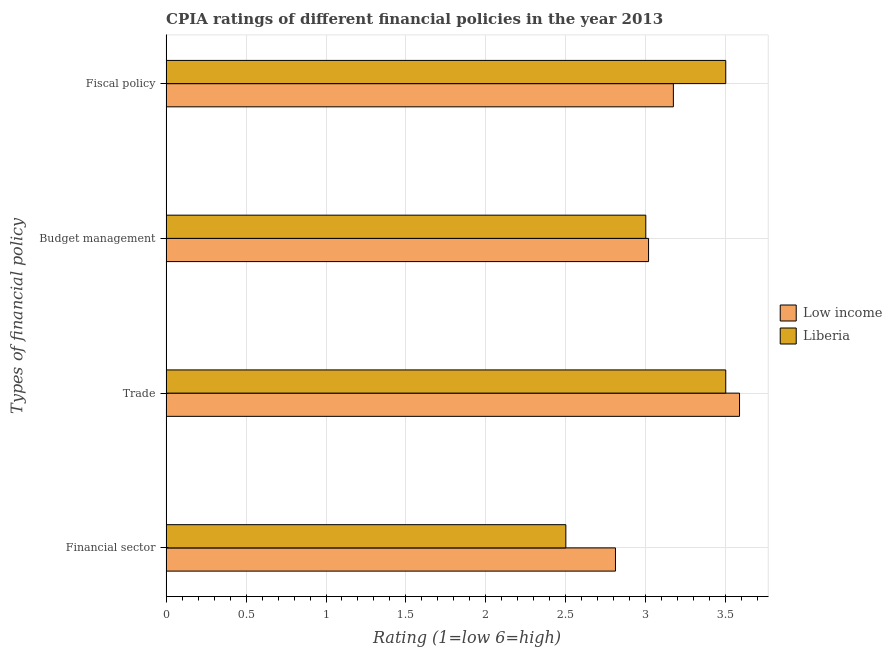How many groups of bars are there?
Make the answer very short. 4. Are the number of bars per tick equal to the number of legend labels?
Offer a very short reply. Yes. Are the number of bars on each tick of the Y-axis equal?
Ensure brevity in your answer.  Yes. How many bars are there on the 1st tick from the top?
Offer a very short reply. 2. What is the label of the 2nd group of bars from the top?
Ensure brevity in your answer.  Budget management. Across all countries, what is the minimum cpia rating of fiscal policy?
Your response must be concise. 3.17. In which country was the cpia rating of budget management maximum?
Offer a terse response. Low income. What is the total cpia rating of fiscal policy in the graph?
Give a very brief answer. 6.67. What is the difference between the cpia rating of trade in Liberia and that in Low income?
Provide a short and direct response. -0.09. What is the difference between the cpia rating of financial sector in Liberia and the cpia rating of trade in Low income?
Provide a succinct answer. -1.09. What is the average cpia rating of financial sector per country?
Your response must be concise. 2.66. What is the difference between the cpia rating of trade and cpia rating of fiscal policy in Low income?
Make the answer very short. 0.41. In how many countries, is the cpia rating of budget management greater than 1.7 ?
Keep it short and to the point. 2. What is the ratio of the cpia rating of fiscal policy in Liberia to that in Low income?
Your answer should be very brief. 1.1. What is the difference between the highest and the second highest cpia rating of fiscal policy?
Provide a short and direct response. 0.33. What is the difference between the highest and the lowest cpia rating of fiscal policy?
Keep it short and to the point. 0.33. What does the 1st bar from the top in Financial sector represents?
Your answer should be compact. Liberia. What does the 2nd bar from the bottom in Fiscal policy represents?
Offer a very short reply. Liberia. Is it the case that in every country, the sum of the cpia rating of financial sector and cpia rating of trade is greater than the cpia rating of budget management?
Provide a short and direct response. Yes. How many bars are there?
Your answer should be compact. 8. What is the difference between two consecutive major ticks on the X-axis?
Your response must be concise. 0.5. Are the values on the major ticks of X-axis written in scientific E-notation?
Provide a succinct answer. No. Does the graph contain grids?
Provide a short and direct response. Yes. What is the title of the graph?
Offer a terse response. CPIA ratings of different financial policies in the year 2013. What is the label or title of the Y-axis?
Keep it short and to the point. Types of financial policy. What is the Rating (1=low 6=high) in Low income in Financial sector?
Give a very brief answer. 2.81. What is the Rating (1=low 6=high) in Liberia in Financial sector?
Provide a short and direct response. 2.5. What is the Rating (1=low 6=high) in Low income in Trade?
Your answer should be compact. 3.59. What is the Rating (1=low 6=high) of Low income in Budget management?
Offer a very short reply. 3.02. What is the Rating (1=low 6=high) in Low income in Fiscal policy?
Keep it short and to the point. 3.17. What is the Rating (1=low 6=high) in Liberia in Fiscal policy?
Offer a terse response. 3.5. Across all Types of financial policy, what is the maximum Rating (1=low 6=high) in Low income?
Offer a very short reply. 3.59. Across all Types of financial policy, what is the maximum Rating (1=low 6=high) of Liberia?
Make the answer very short. 3.5. Across all Types of financial policy, what is the minimum Rating (1=low 6=high) in Low income?
Your answer should be compact. 2.81. What is the total Rating (1=low 6=high) in Low income in the graph?
Provide a succinct answer. 12.59. What is the difference between the Rating (1=low 6=high) of Low income in Financial sector and that in Trade?
Make the answer very short. -0.78. What is the difference between the Rating (1=low 6=high) of Low income in Financial sector and that in Budget management?
Make the answer very short. -0.21. What is the difference between the Rating (1=low 6=high) of Low income in Financial sector and that in Fiscal policy?
Provide a succinct answer. -0.36. What is the difference between the Rating (1=low 6=high) of Liberia in Financial sector and that in Fiscal policy?
Provide a succinct answer. -1. What is the difference between the Rating (1=low 6=high) of Low income in Trade and that in Budget management?
Offer a terse response. 0.57. What is the difference between the Rating (1=low 6=high) of Liberia in Trade and that in Budget management?
Give a very brief answer. 0.5. What is the difference between the Rating (1=low 6=high) in Low income in Trade and that in Fiscal policy?
Give a very brief answer. 0.41. What is the difference between the Rating (1=low 6=high) in Liberia in Trade and that in Fiscal policy?
Offer a very short reply. 0. What is the difference between the Rating (1=low 6=high) of Low income in Budget management and that in Fiscal policy?
Your response must be concise. -0.16. What is the difference between the Rating (1=low 6=high) of Liberia in Budget management and that in Fiscal policy?
Offer a very short reply. -0.5. What is the difference between the Rating (1=low 6=high) of Low income in Financial sector and the Rating (1=low 6=high) of Liberia in Trade?
Ensure brevity in your answer.  -0.69. What is the difference between the Rating (1=low 6=high) in Low income in Financial sector and the Rating (1=low 6=high) in Liberia in Budget management?
Offer a terse response. -0.19. What is the difference between the Rating (1=low 6=high) in Low income in Financial sector and the Rating (1=low 6=high) in Liberia in Fiscal policy?
Your response must be concise. -0.69. What is the difference between the Rating (1=low 6=high) of Low income in Trade and the Rating (1=low 6=high) of Liberia in Budget management?
Your answer should be very brief. 0.59. What is the difference between the Rating (1=low 6=high) in Low income in Trade and the Rating (1=low 6=high) in Liberia in Fiscal policy?
Make the answer very short. 0.09. What is the difference between the Rating (1=low 6=high) in Low income in Budget management and the Rating (1=low 6=high) in Liberia in Fiscal policy?
Provide a succinct answer. -0.48. What is the average Rating (1=low 6=high) of Low income per Types of financial policy?
Give a very brief answer. 3.15. What is the average Rating (1=low 6=high) of Liberia per Types of financial policy?
Provide a short and direct response. 3.12. What is the difference between the Rating (1=low 6=high) of Low income and Rating (1=low 6=high) of Liberia in Financial sector?
Make the answer very short. 0.31. What is the difference between the Rating (1=low 6=high) of Low income and Rating (1=low 6=high) of Liberia in Trade?
Provide a short and direct response. 0.09. What is the difference between the Rating (1=low 6=high) in Low income and Rating (1=low 6=high) in Liberia in Budget management?
Your answer should be compact. 0.02. What is the difference between the Rating (1=low 6=high) in Low income and Rating (1=low 6=high) in Liberia in Fiscal policy?
Provide a succinct answer. -0.33. What is the ratio of the Rating (1=low 6=high) of Low income in Financial sector to that in Trade?
Offer a very short reply. 0.78. What is the ratio of the Rating (1=low 6=high) of Low income in Financial sector to that in Budget management?
Offer a terse response. 0.93. What is the ratio of the Rating (1=low 6=high) in Liberia in Financial sector to that in Budget management?
Ensure brevity in your answer.  0.83. What is the ratio of the Rating (1=low 6=high) in Low income in Financial sector to that in Fiscal policy?
Give a very brief answer. 0.89. What is the ratio of the Rating (1=low 6=high) of Low income in Trade to that in Budget management?
Provide a succinct answer. 1.19. What is the ratio of the Rating (1=low 6=high) in Liberia in Trade to that in Budget management?
Your response must be concise. 1.17. What is the ratio of the Rating (1=low 6=high) in Low income in Trade to that in Fiscal policy?
Offer a very short reply. 1.13. What is the ratio of the Rating (1=low 6=high) in Low income in Budget management to that in Fiscal policy?
Keep it short and to the point. 0.95. What is the ratio of the Rating (1=low 6=high) in Liberia in Budget management to that in Fiscal policy?
Provide a succinct answer. 0.86. What is the difference between the highest and the second highest Rating (1=low 6=high) in Low income?
Your answer should be compact. 0.41. What is the difference between the highest and the lowest Rating (1=low 6=high) in Low income?
Offer a very short reply. 0.78. What is the difference between the highest and the lowest Rating (1=low 6=high) of Liberia?
Offer a terse response. 1. 